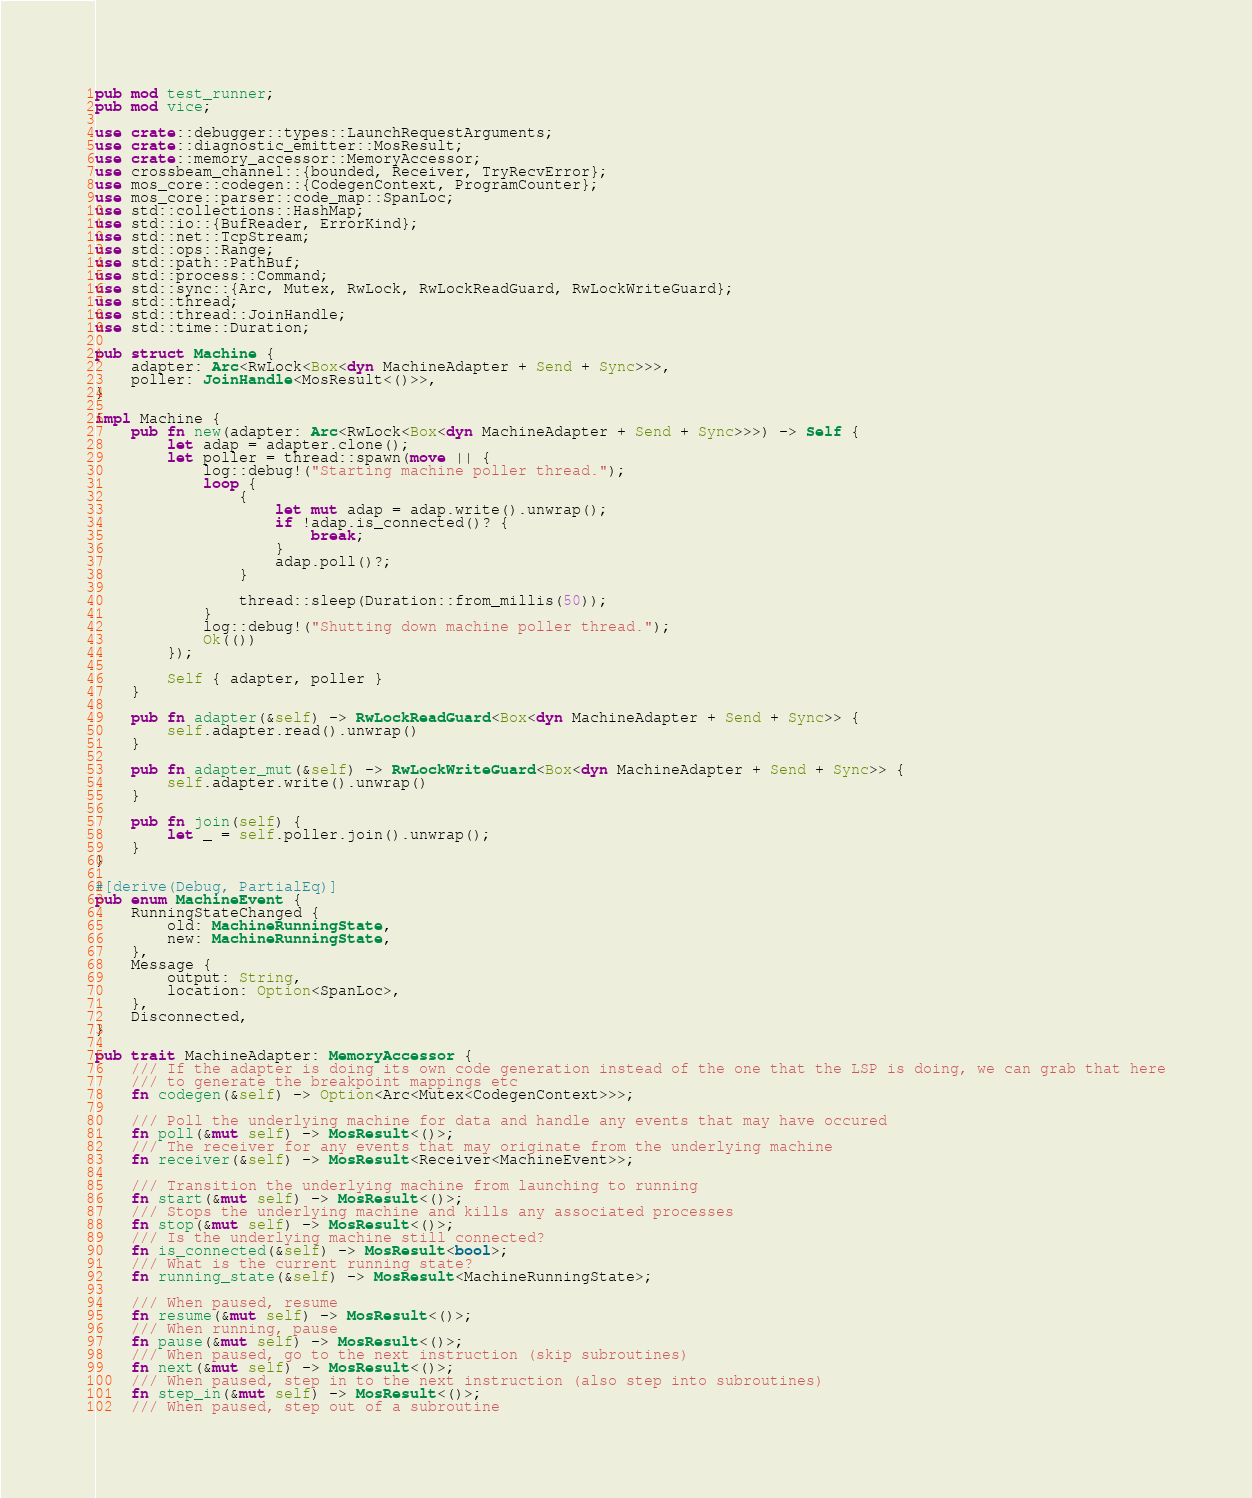Convert code to text. <code><loc_0><loc_0><loc_500><loc_500><_Rust_>pub mod test_runner;
pub mod vice;

use crate::debugger::types::LaunchRequestArguments;
use crate::diagnostic_emitter::MosResult;
use crate::memory_accessor::MemoryAccessor;
use crossbeam_channel::{bounded, Receiver, TryRecvError};
use mos_core::codegen::{CodegenContext, ProgramCounter};
use mos_core::parser::code_map::SpanLoc;
use std::collections::HashMap;
use std::io::{BufReader, ErrorKind};
use std::net::TcpStream;
use std::ops::Range;
use std::path::PathBuf;
use std::process::Command;
use std::sync::{Arc, Mutex, RwLock, RwLockReadGuard, RwLockWriteGuard};
use std::thread;
use std::thread::JoinHandle;
use std::time::Duration;

pub struct Machine {
    adapter: Arc<RwLock<Box<dyn MachineAdapter + Send + Sync>>>,
    poller: JoinHandle<MosResult<()>>,
}

impl Machine {
    pub fn new(adapter: Arc<RwLock<Box<dyn MachineAdapter + Send + Sync>>>) -> Self {
        let adap = adapter.clone();
        let poller = thread::spawn(move || {
            log::debug!("Starting machine poller thread.");
            loop {
                {
                    let mut adap = adap.write().unwrap();
                    if !adap.is_connected()? {
                        break;
                    }
                    adap.poll()?;
                }

                thread::sleep(Duration::from_millis(50));
            }
            log::debug!("Shutting down machine poller thread.");
            Ok(())
        });

        Self { adapter, poller }
    }

    pub fn adapter(&self) -> RwLockReadGuard<Box<dyn MachineAdapter + Send + Sync>> {
        self.adapter.read().unwrap()
    }

    pub fn adapter_mut(&self) -> RwLockWriteGuard<Box<dyn MachineAdapter + Send + Sync>> {
        self.adapter.write().unwrap()
    }

    pub fn join(self) {
        let _ = self.poller.join().unwrap();
    }
}

#[derive(Debug, PartialEq)]
pub enum MachineEvent {
    RunningStateChanged {
        old: MachineRunningState,
        new: MachineRunningState,
    },
    Message {
        output: String,
        location: Option<SpanLoc>,
    },
    Disconnected,
}

pub trait MachineAdapter: MemoryAccessor {
    /// If the adapter is doing its own code generation instead of the one that the LSP is doing, we can grab that here
    /// to generate the breakpoint mappings etc
    fn codegen(&self) -> Option<Arc<Mutex<CodegenContext>>>;

    /// Poll the underlying machine for data and handle any events that may have occured
    fn poll(&mut self) -> MosResult<()>;
    /// The receiver for any events that may originate from the underlying machine
    fn receiver(&self) -> MosResult<Receiver<MachineEvent>>;

    /// Transition the underlying machine from launching to running
    fn start(&mut self) -> MosResult<()>;
    /// Stops the underlying machine and kills any associated processes
    fn stop(&mut self) -> MosResult<()>;
    /// Is the underlying machine still connected?
    fn is_connected(&self) -> MosResult<bool>;
    /// What is the current running state?
    fn running_state(&self) -> MosResult<MachineRunningState>;

    /// When paused, resume
    fn resume(&mut self) -> MosResult<()>;
    /// When running, pause
    fn pause(&mut self) -> MosResult<()>;
    /// When paused, go to the next instruction (skip subroutines)
    fn next(&mut self) -> MosResult<()>;
    /// When paused, step in to the next instruction (also step into subroutines)
    fn step_in(&mut self) -> MosResult<()>;
    /// When paused, step out of a subroutine</code> 